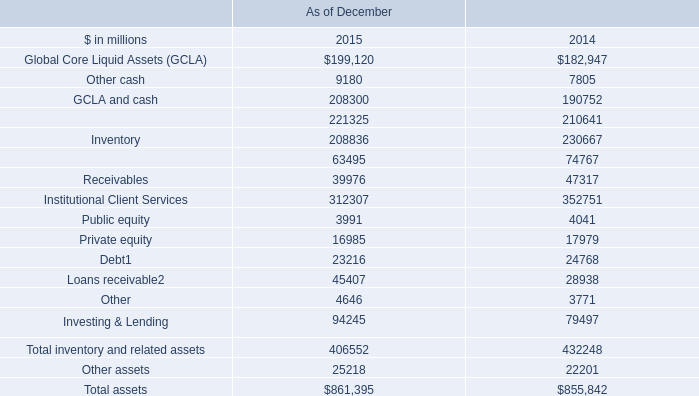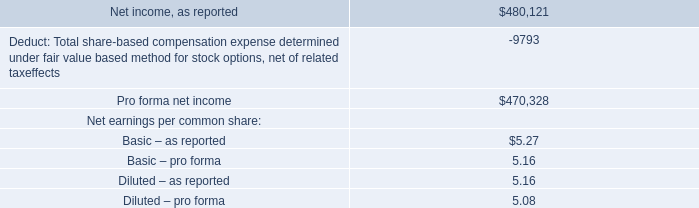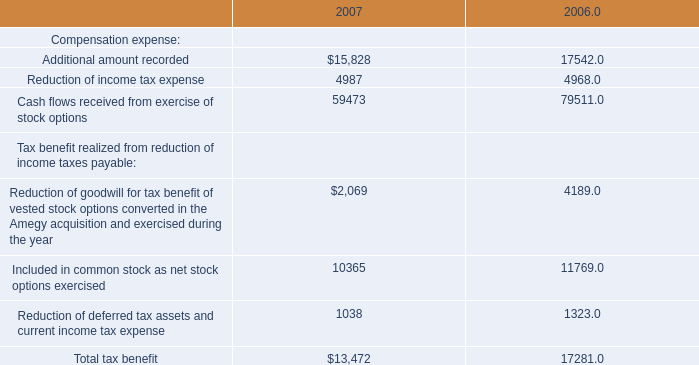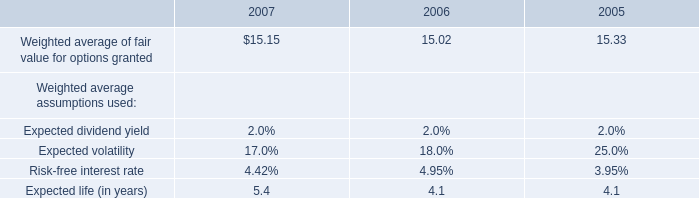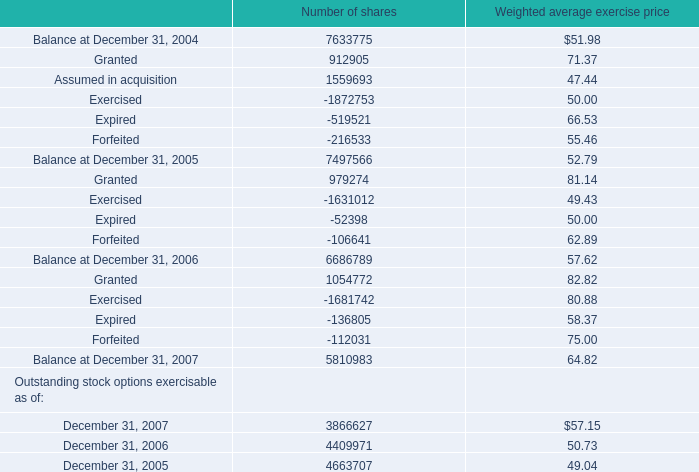What's the sum of the Balance at December 31, for Number of sharesin the years where Additional amount recorded for Compensation expense is positive? 
Computations: (6686789 + 5810983)
Answer: 12497772.0. 